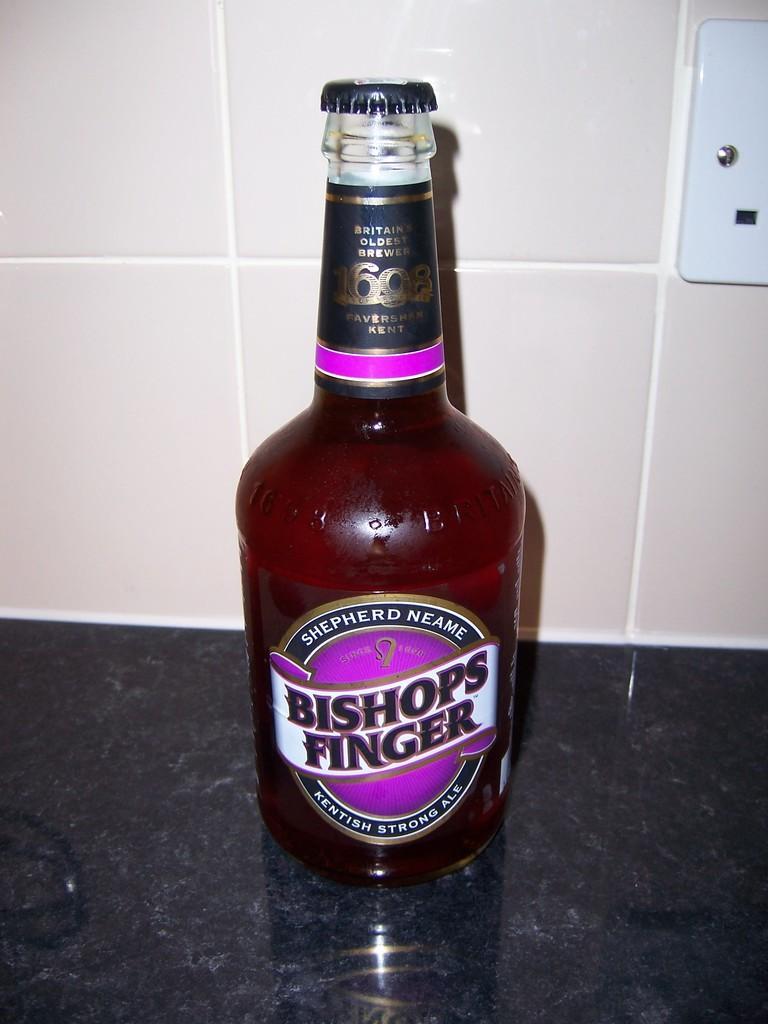Please provide a concise description of this image. There is a bottle which is filled with some liquid, this bottle is on the counter top of the kitchen. In the background i could see some tiles and to right up corner of the picture i could see some electrical board and the bottle has lid covered. 